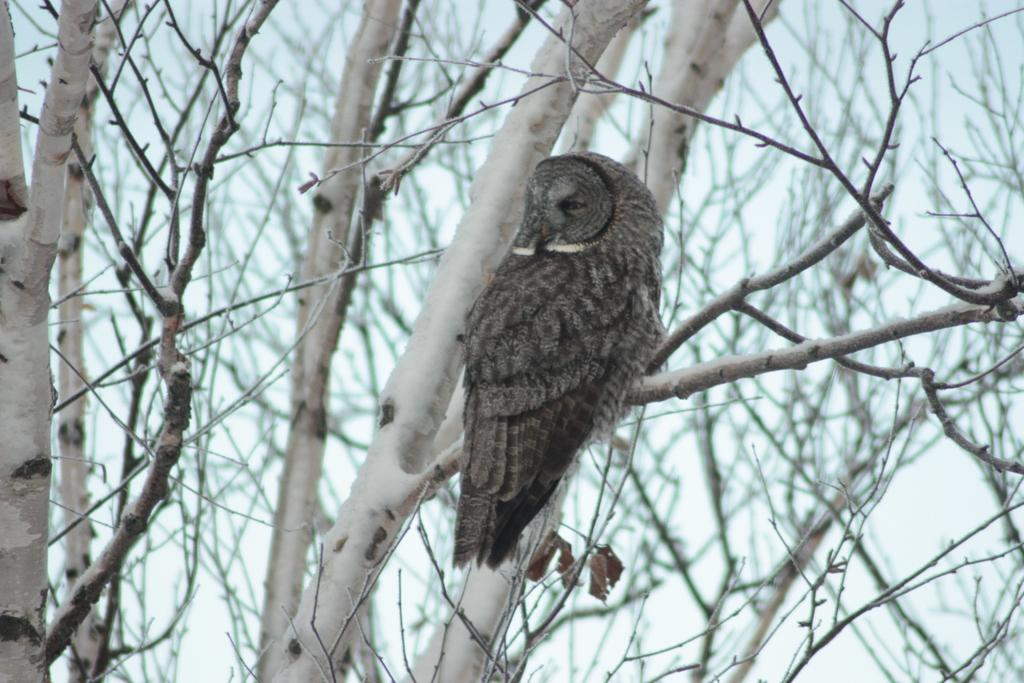What animal is in the picture? There is an owl in the picture. Where is the owl located? The owl is on a branch. What can be seen in the background of the picture? There are trees visible in the background of the picture. How would you describe the background of the image? The background of the image is blurred. What route does the owl take to get to the pizzas in the image? There are no pizzas present in the image, so the owl does not have a route to get to them. 